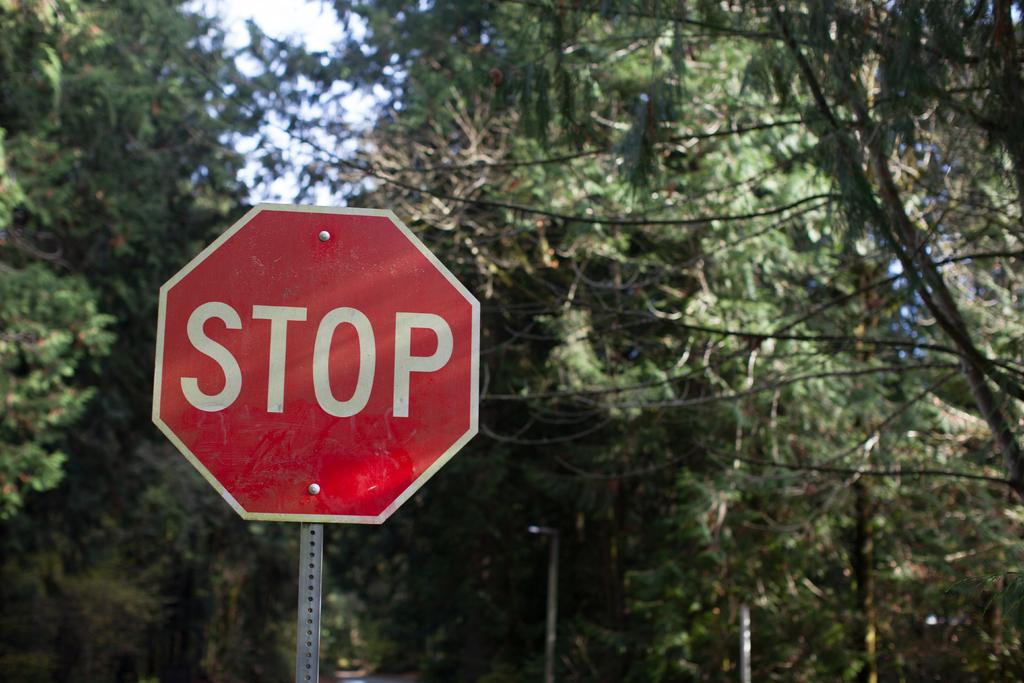<image>
Offer a succinct explanation of the picture presented. A red and white stop sign is standing in front of several trees. 